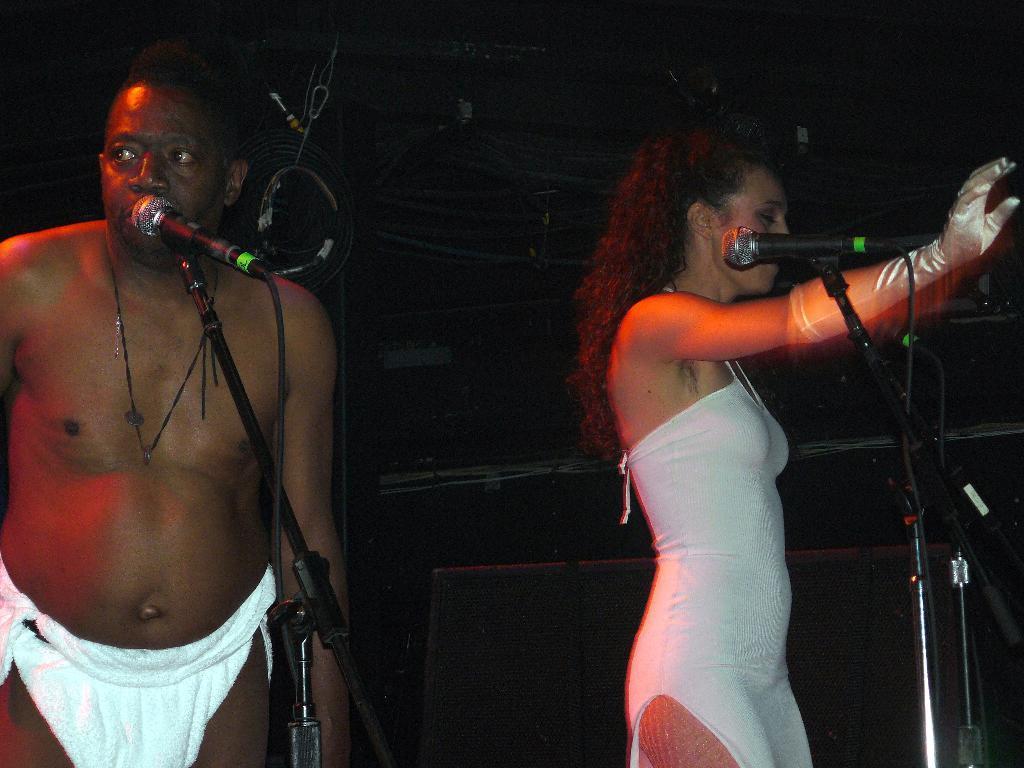In one or two sentences, can you explain what this image depicts? In the picture I can see a man standing near the mic, which is fixed to the stand. On the left side of the image we can see a woman wearing a white color dress is having a mic to stand in front of her. The background of the image is dark 